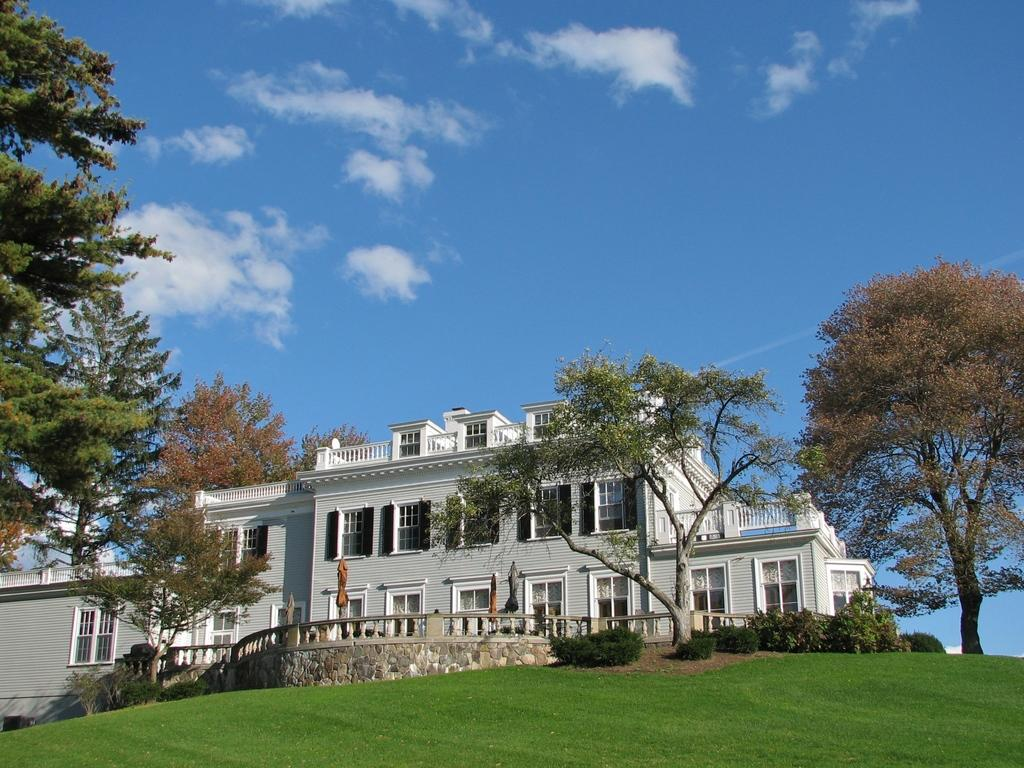What type of structure is visible in the image? There is a building with windows in the image. What natural elements can be seen in the image? There are trees and grass visible in the image. What is visible in the background of the image? The sky is visible in the background of the image. What can be observed in the sky? Clouds are present in the sky. Is there a spring or fountain visible in the image? There is no spring or fountain present in the image. Is the building's roof visible in the image? The roof of the building is not visible in the image; only the windows are shown. 